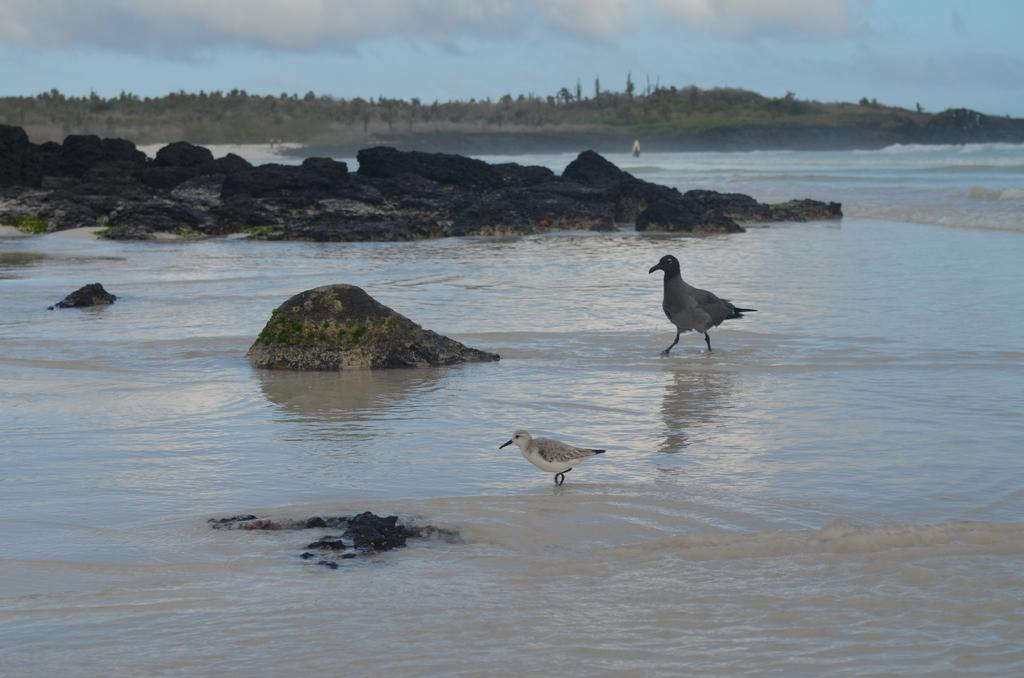How many birds can be seen in the image? There are 2 birds in the image. What are the birds doing in the image? The birds are standing on the water. What can be seen in the background of the image? The area around the water is surrounded by trees. What other objects are present in the surroundings? Rocks are present in the surroundings. What type of ball is being used by the birds to play in the image? There is no ball present in the image; the birds are standing on the water. Can you describe the spring that the birds are jumping on in the image? There is no spring present in the image; the birds are standing on the water. 